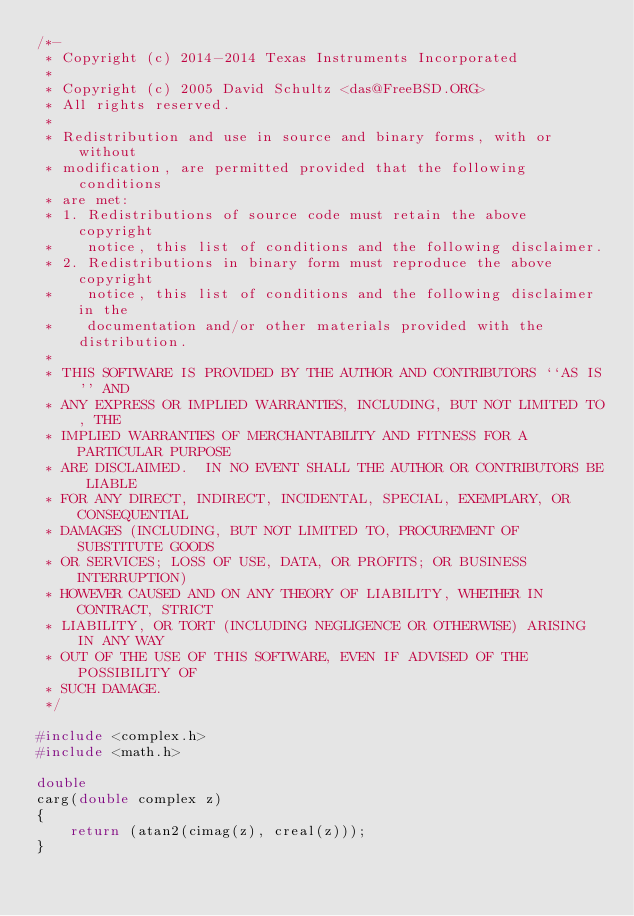Convert code to text. <code><loc_0><loc_0><loc_500><loc_500><_C_>/*-
 * Copyright (c) 2014-2014 Texas Instruments Incorporated
 *
 * Copyright (c) 2005 David Schultz <das@FreeBSD.ORG>
 * All rights reserved.
 *
 * Redistribution and use in source and binary forms, with or without
 * modification, are permitted provided that the following conditions
 * are met:
 * 1. Redistributions of source code must retain the above copyright
 *    notice, this list of conditions and the following disclaimer.
 * 2. Redistributions in binary form must reproduce the above copyright
 *    notice, this list of conditions and the following disclaimer in the
 *    documentation and/or other materials provided with the distribution.
 *
 * THIS SOFTWARE IS PROVIDED BY THE AUTHOR AND CONTRIBUTORS ``AS IS'' AND
 * ANY EXPRESS OR IMPLIED WARRANTIES, INCLUDING, BUT NOT LIMITED TO, THE
 * IMPLIED WARRANTIES OF MERCHANTABILITY AND FITNESS FOR A PARTICULAR PURPOSE
 * ARE DISCLAIMED.  IN NO EVENT SHALL THE AUTHOR OR CONTRIBUTORS BE LIABLE
 * FOR ANY DIRECT, INDIRECT, INCIDENTAL, SPECIAL, EXEMPLARY, OR CONSEQUENTIAL
 * DAMAGES (INCLUDING, BUT NOT LIMITED TO, PROCUREMENT OF SUBSTITUTE GOODS
 * OR SERVICES; LOSS OF USE, DATA, OR PROFITS; OR BUSINESS INTERRUPTION)
 * HOWEVER CAUSED AND ON ANY THEORY OF LIABILITY, WHETHER IN CONTRACT, STRICT
 * LIABILITY, OR TORT (INCLUDING NEGLIGENCE OR OTHERWISE) ARISING IN ANY WAY
 * OUT OF THE USE OF THIS SOFTWARE, EVEN IF ADVISED OF THE POSSIBILITY OF
 * SUCH DAMAGE.
 */

#include <complex.h>
#include <math.h>

double
carg(double complex z)
{
	return (atan2(cimag(z), creal(z)));
}
</code> 